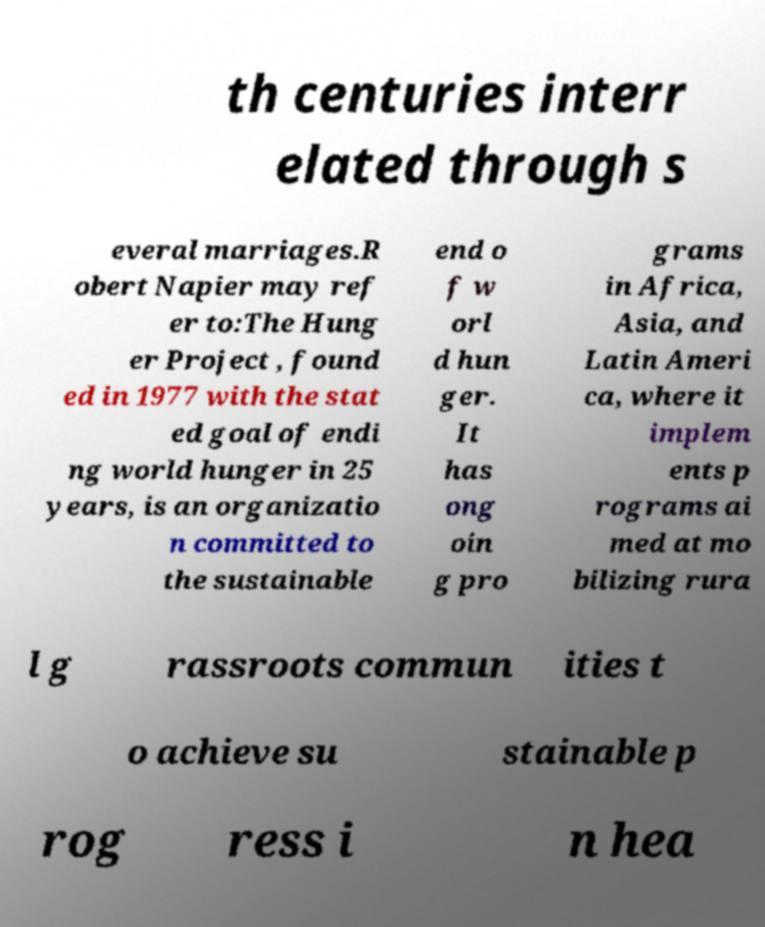Could you extract and type out the text from this image? th centuries interr elated through s everal marriages.R obert Napier may ref er to:The Hung er Project , found ed in 1977 with the stat ed goal of endi ng world hunger in 25 years, is an organizatio n committed to the sustainable end o f w orl d hun ger. It has ong oin g pro grams in Africa, Asia, and Latin Ameri ca, where it implem ents p rograms ai med at mo bilizing rura l g rassroots commun ities t o achieve su stainable p rog ress i n hea 